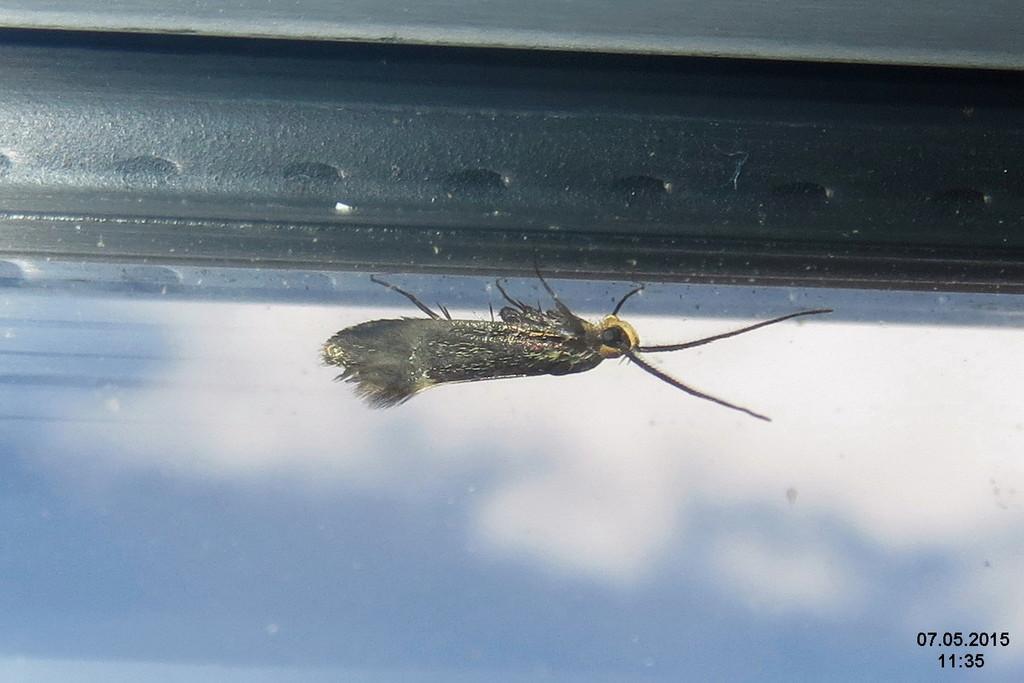Describe this image in one or two sentences. At the bottom of the image we can see a glass window. Through the window we can see some clouds in the sky. In the middle of the image we can see an insect. At the top of the image we can see a wall. 